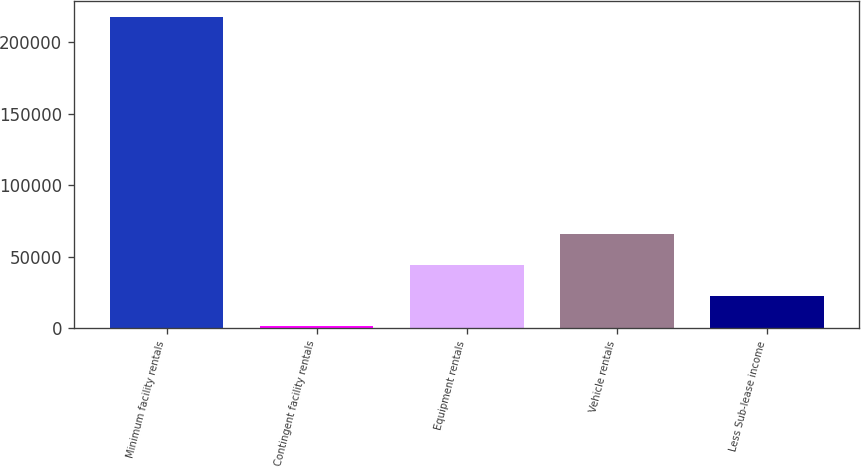<chart> <loc_0><loc_0><loc_500><loc_500><bar_chart><fcel>Minimum facility rentals<fcel>Contingent facility rentals<fcel>Equipment rentals<fcel>Vehicle rentals<fcel>Less Sub-lease income<nl><fcel>217588<fcel>1090<fcel>44389.6<fcel>66039.4<fcel>22739.8<nl></chart> 